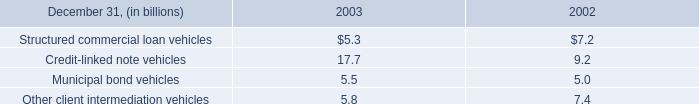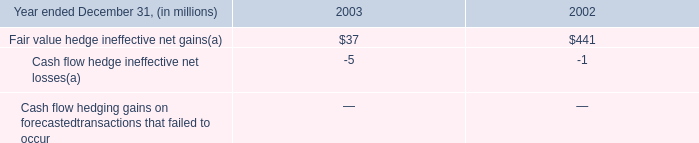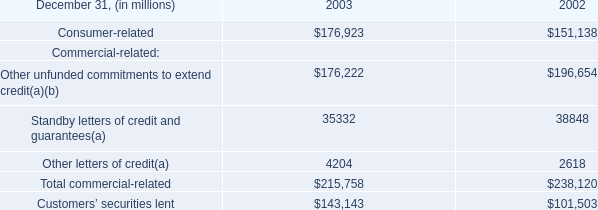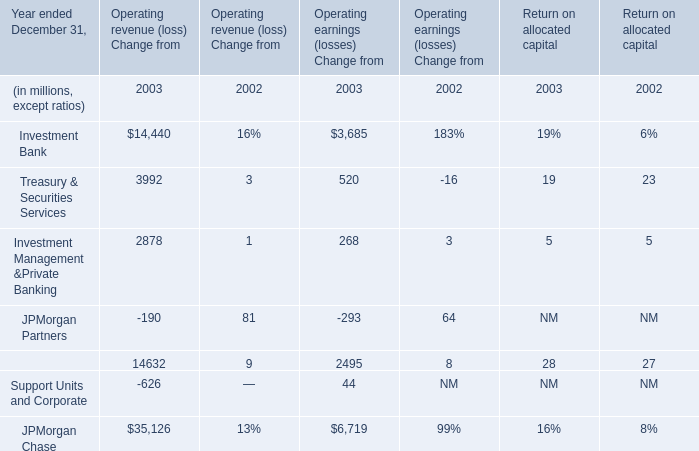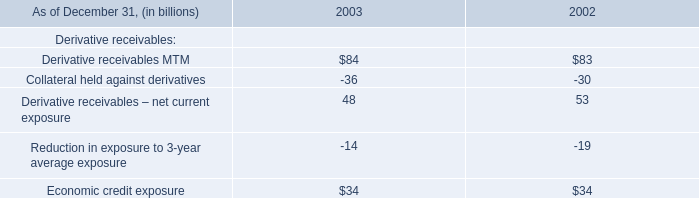what was the decline in commercial paper issued by conduits during 2003 , in b? 
Computations: (17.5 - 11.7)
Answer: 5.8. 